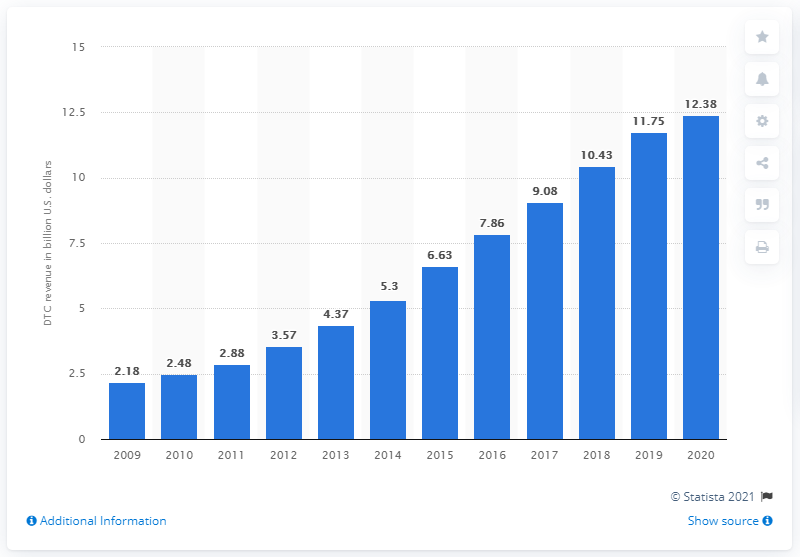List a handful of essential elements in this visual. Nike's direct-to-consumer revenue in 2020 was 12.38. 